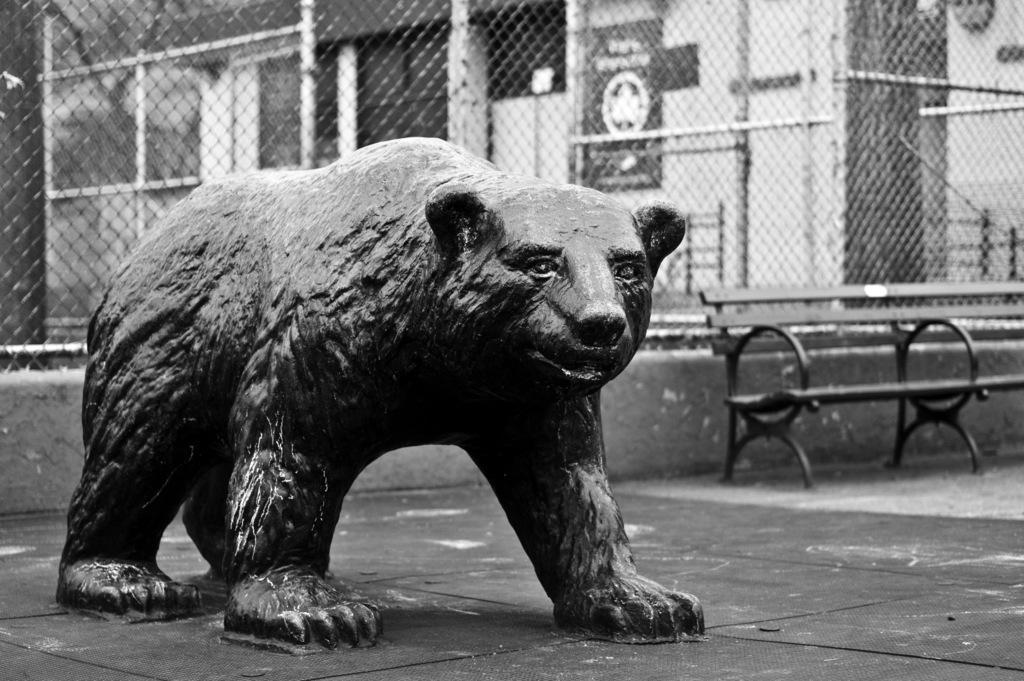Can you describe this image briefly? This is black and white picture where we can see a statue of bear. Behind fencing, bench and building is present. 